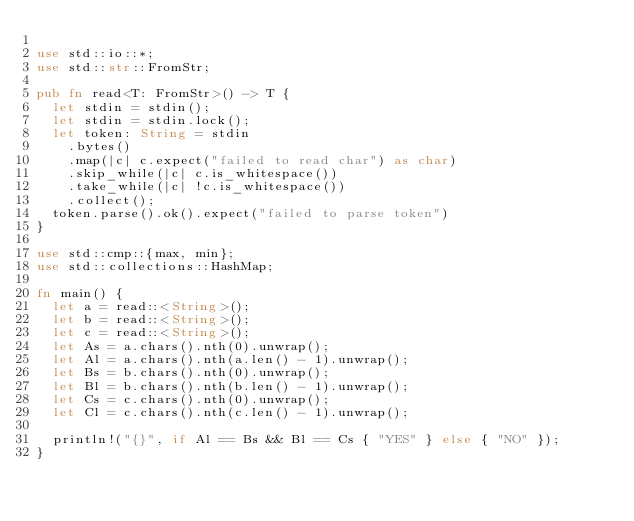<code> <loc_0><loc_0><loc_500><loc_500><_Rust_>
use std::io::*;
use std::str::FromStr;

pub fn read<T: FromStr>() -> T {
  let stdin = stdin();
  let stdin = stdin.lock();
  let token: String = stdin
    .bytes()
    .map(|c| c.expect("failed to read char") as char)
    .skip_while(|c| c.is_whitespace())
    .take_while(|c| !c.is_whitespace())
    .collect();
  token.parse().ok().expect("failed to parse token")
}

use std::cmp::{max, min};
use std::collections::HashMap;

fn main() {
  let a = read::<String>();
  let b = read::<String>();
  let c = read::<String>();
  let As = a.chars().nth(0).unwrap();
  let Al = a.chars().nth(a.len() - 1).unwrap();
  let Bs = b.chars().nth(0).unwrap();
  let Bl = b.chars().nth(b.len() - 1).unwrap();
  let Cs = c.chars().nth(0).unwrap();
  let Cl = c.chars().nth(c.len() - 1).unwrap();

  println!("{}", if Al == Bs && Bl == Cs { "YES" } else { "NO" });
}</code> 